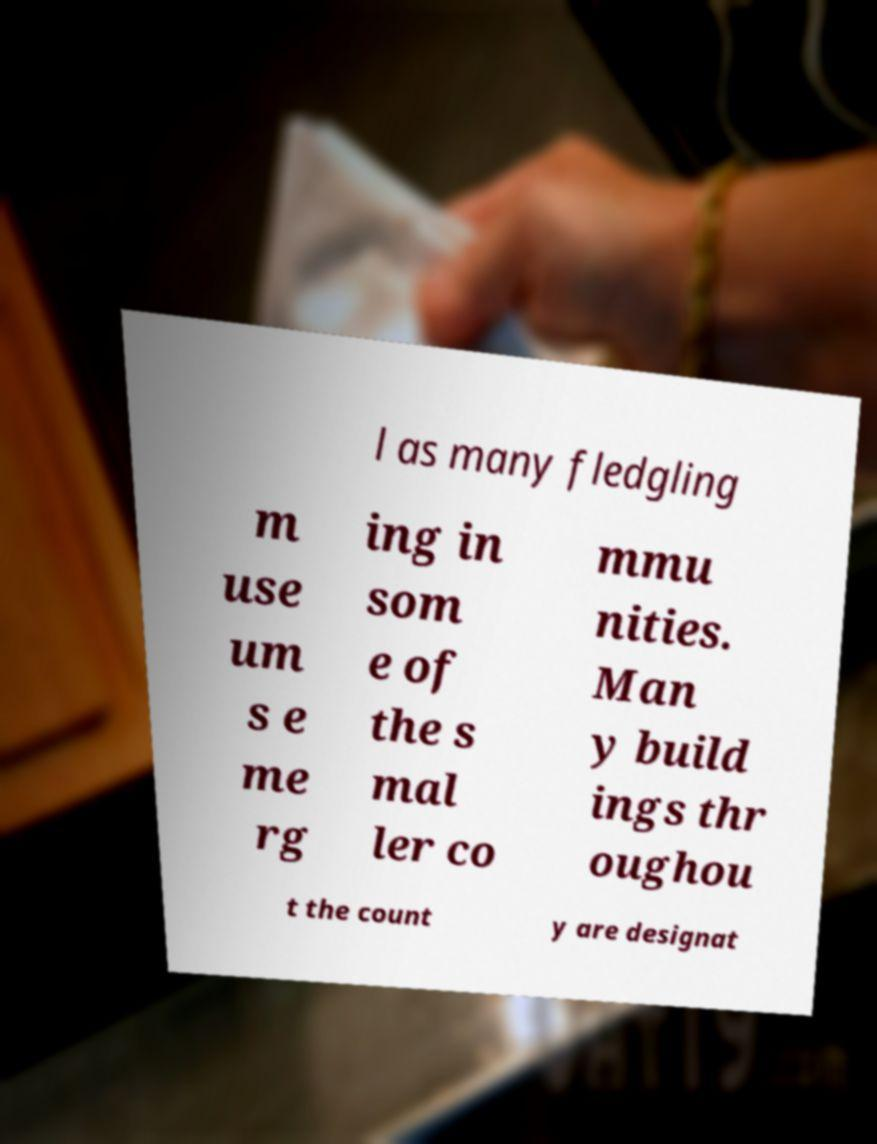Can you read and provide the text displayed in the image?This photo seems to have some interesting text. Can you extract and type it out for me? l as many fledgling m use um s e me rg ing in som e of the s mal ler co mmu nities. Man y build ings thr oughou t the count y are designat 